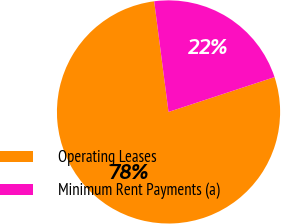Convert chart. <chart><loc_0><loc_0><loc_500><loc_500><pie_chart><fcel>Operating Leases<fcel>Minimum Rent Payments (a)<nl><fcel>78.0%<fcel>22.0%<nl></chart> 